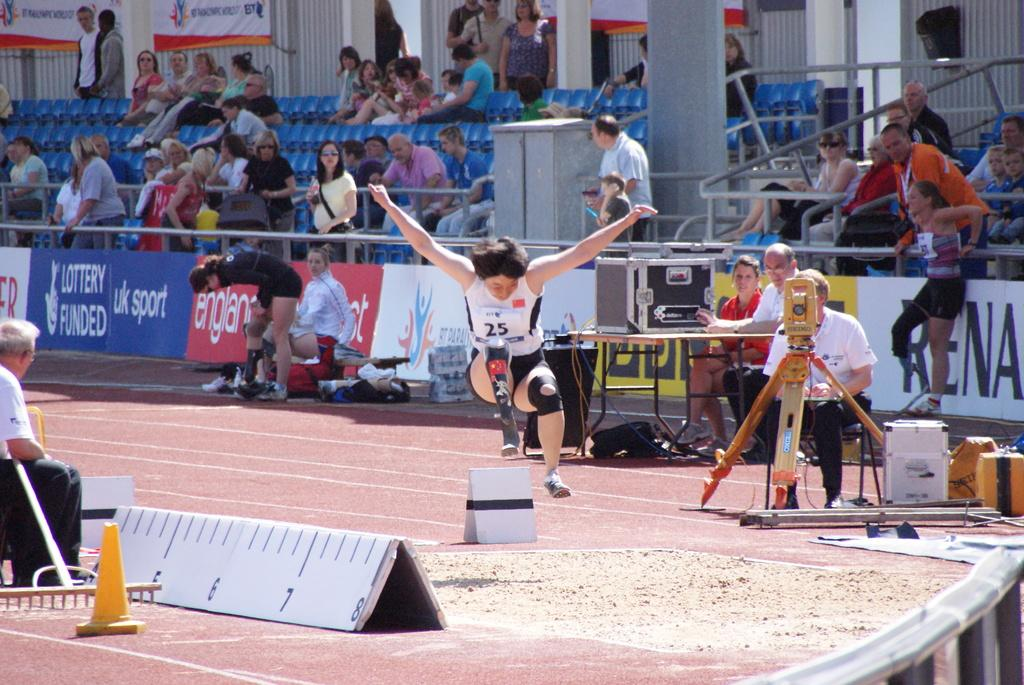<image>
Relay a brief, clear account of the picture shown. The athlete wearing bib number 25 does the long jump. 